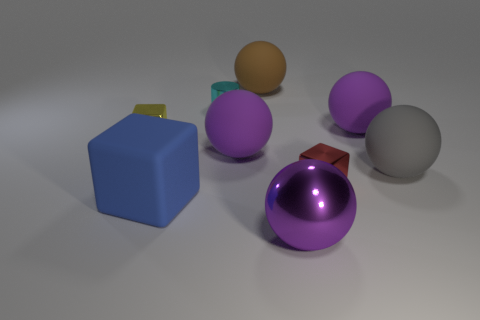There is a tiny cyan metal thing; is it the same shape as the purple metal thing that is in front of the yellow block? The tiny cyan object is not the same shape as the purple object. The cyan item is a thin, rectangularly shaped tab, whereas the purple object is spherical. They have distinct shapes with the Cyan item resembling more of a flat tag or plate, and the purple one being rounded in form. 